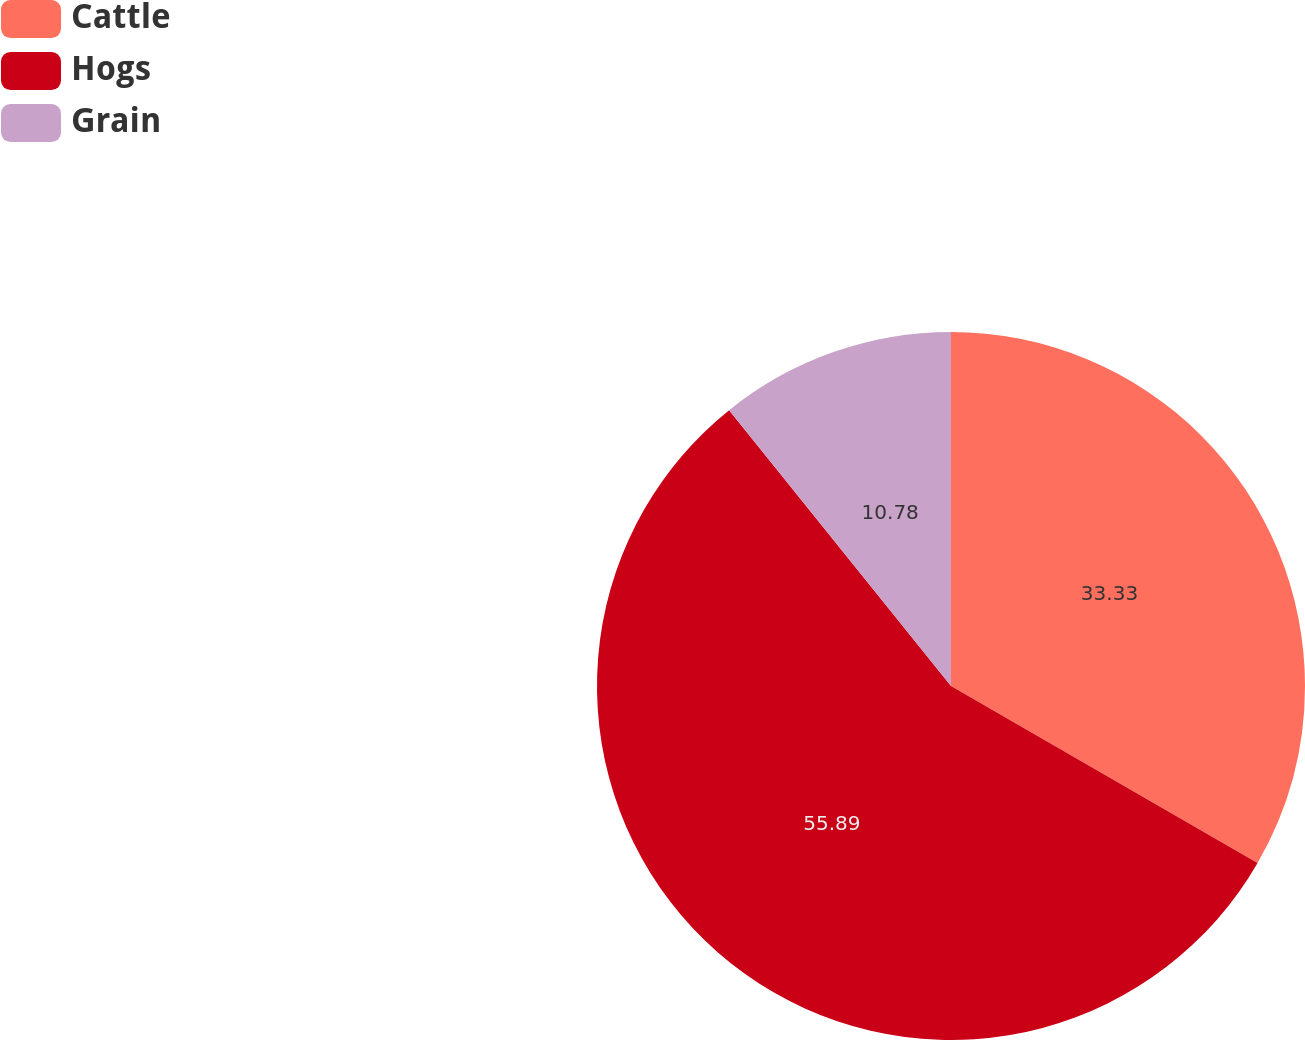Convert chart to OTSL. <chart><loc_0><loc_0><loc_500><loc_500><pie_chart><fcel>Cattle<fcel>Hogs<fcel>Grain<nl><fcel>33.33%<fcel>55.88%<fcel>10.78%<nl></chart> 